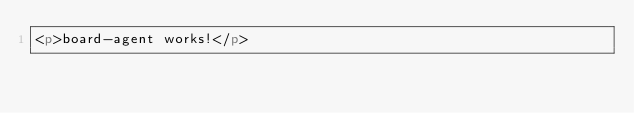<code> <loc_0><loc_0><loc_500><loc_500><_HTML_><p>board-agent works!</p>
</code> 